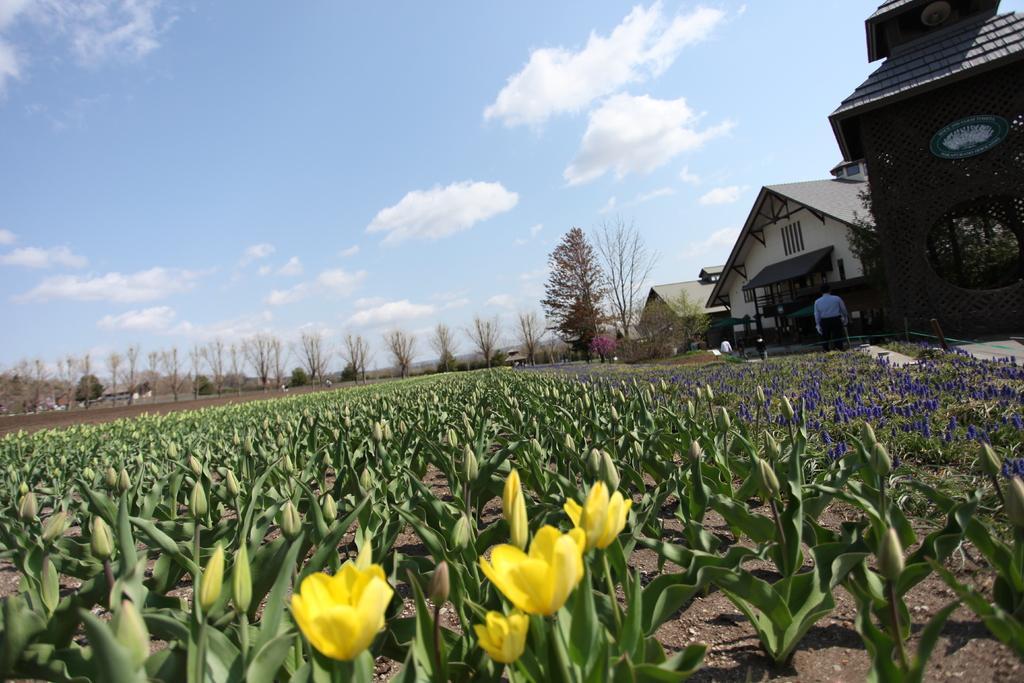How would you summarize this image in a sentence or two? There are plants which has yellow and violet flowers on it and there are buildings in the right corner and there are trees in the background. 